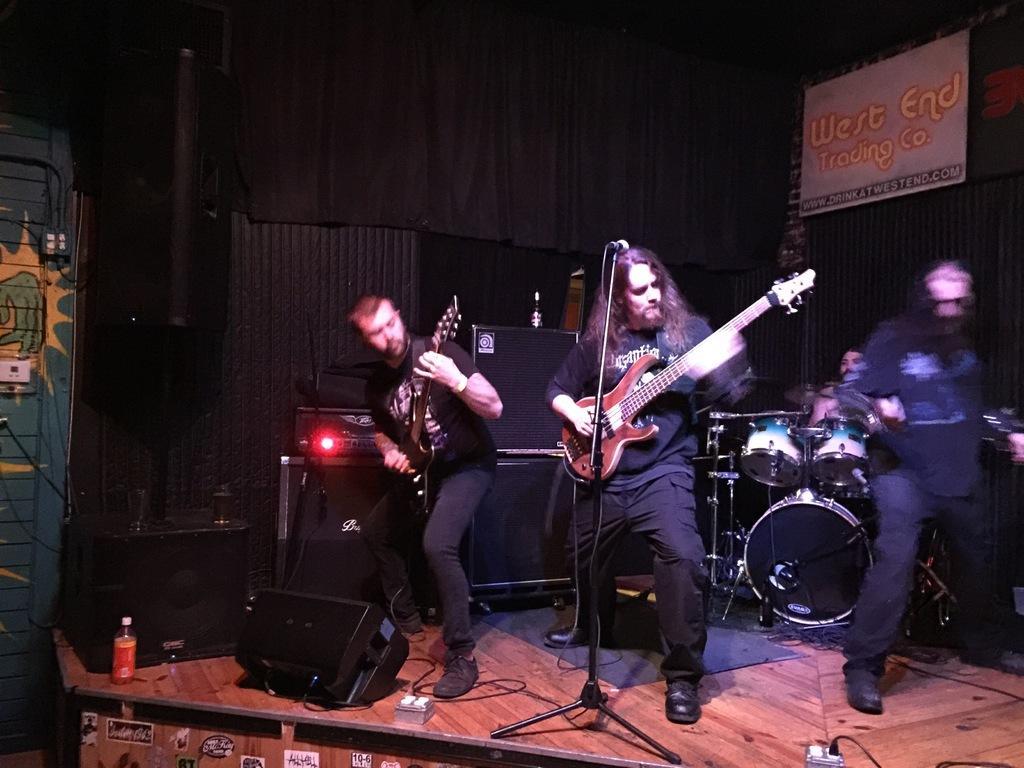How would you summarize this image in a sentence or two? This image is clicked in a musical concert. There are people who are playing musical instruments. There are wires in the bottom. There is a bottle in the bottom. 